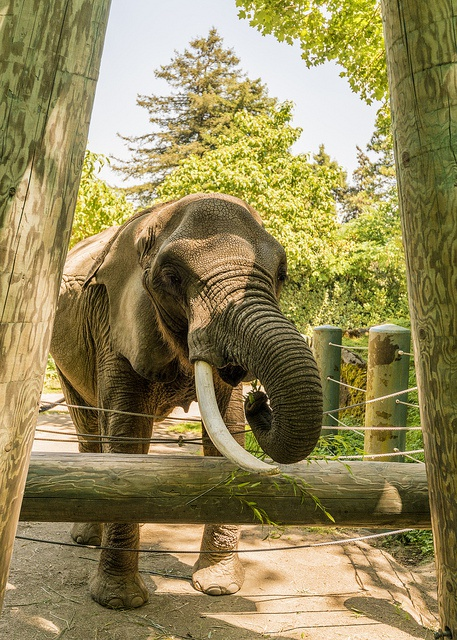Describe the objects in this image and their specific colors. I can see a elephant in olive, black, and tan tones in this image. 